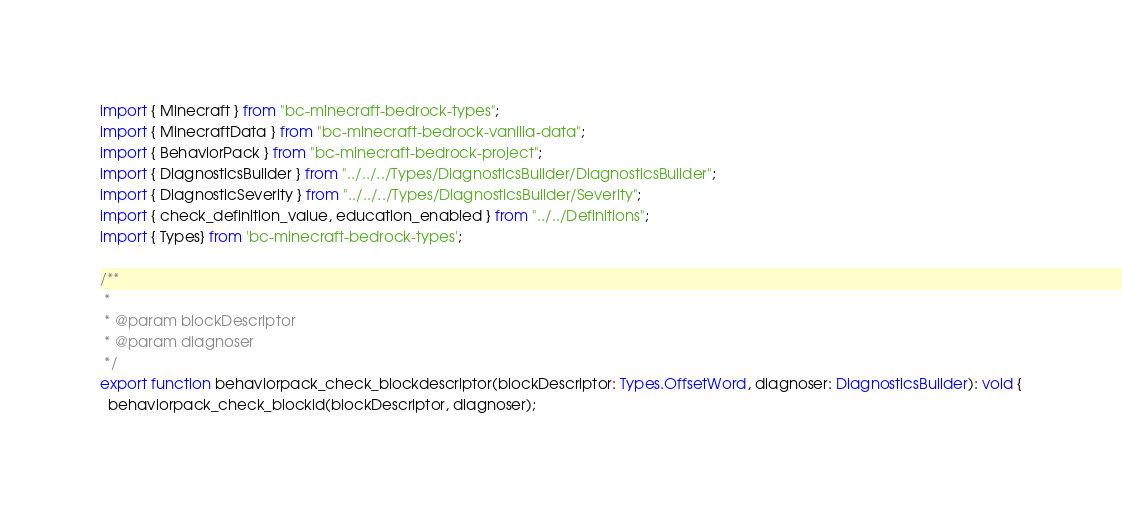<code> <loc_0><loc_0><loc_500><loc_500><_TypeScript_>import { Minecraft } from "bc-minecraft-bedrock-types";
import { MinecraftData } from "bc-minecraft-bedrock-vanilla-data";
import { BehaviorPack } from "bc-minecraft-bedrock-project";
import { DiagnosticsBuilder } from "../../../Types/DiagnosticsBuilder/DiagnosticsBuilder";
import { DiagnosticSeverity } from "../../../Types/DiagnosticsBuilder/Severity";
import { check_definition_value, education_enabled } from "../../Definitions";
import { Types} from 'bc-minecraft-bedrock-types';

/**
 *
 * @param blockDescriptor
 * @param diagnoser
 */
export function behaviorpack_check_blockdescriptor(blockDescriptor: Types.OffsetWord, diagnoser: DiagnosticsBuilder): void {
  behaviorpack_check_blockid(blockDescriptor, diagnoser);</code> 